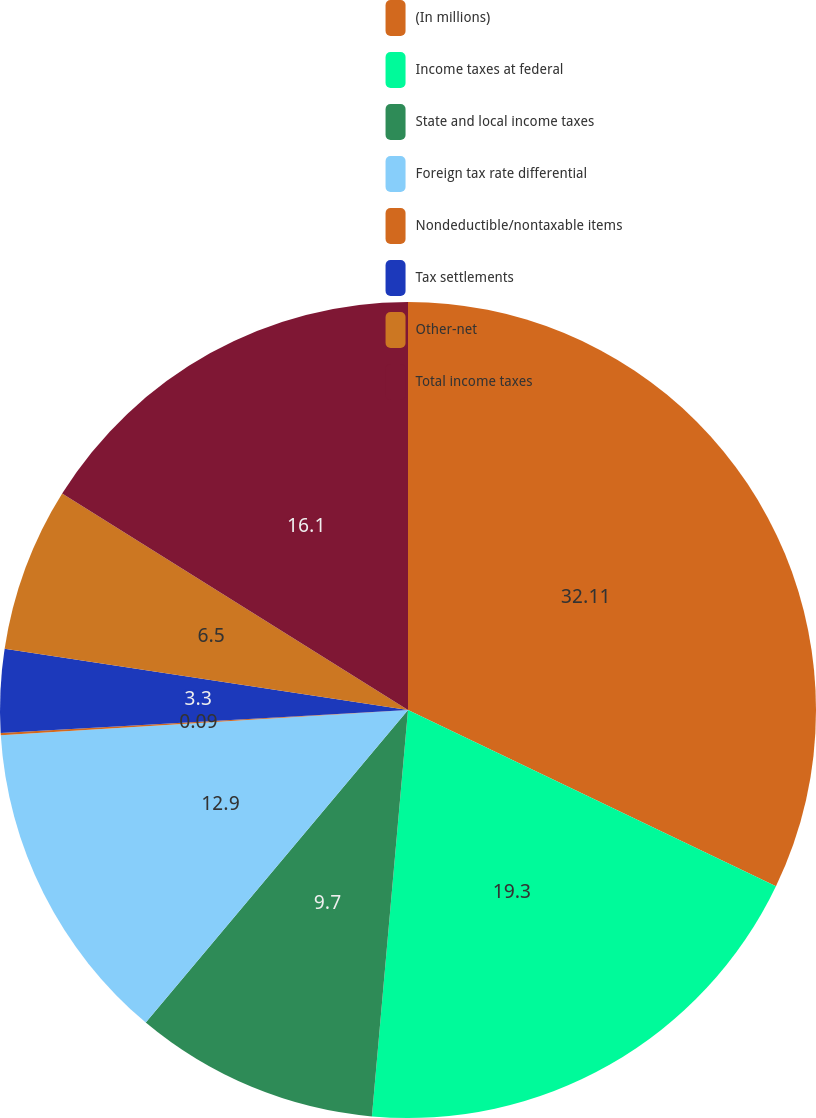Convert chart to OTSL. <chart><loc_0><loc_0><loc_500><loc_500><pie_chart><fcel>(In millions)<fcel>Income taxes at federal<fcel>State and local income taxes<fcel>Foreign tax rate differential<fcel>Nondeductible/nontaxable items<fcel>Tax settlements<fcel>Other-net<fcel>Total income taxes<nl><fcel>32.11%<fcel>19.3%<fcel>9.7%<fcel>12.9%<fcel>0.09%<fcel>3.3%<fcel>6.5%<fcel>16.1%<nl></chart> 